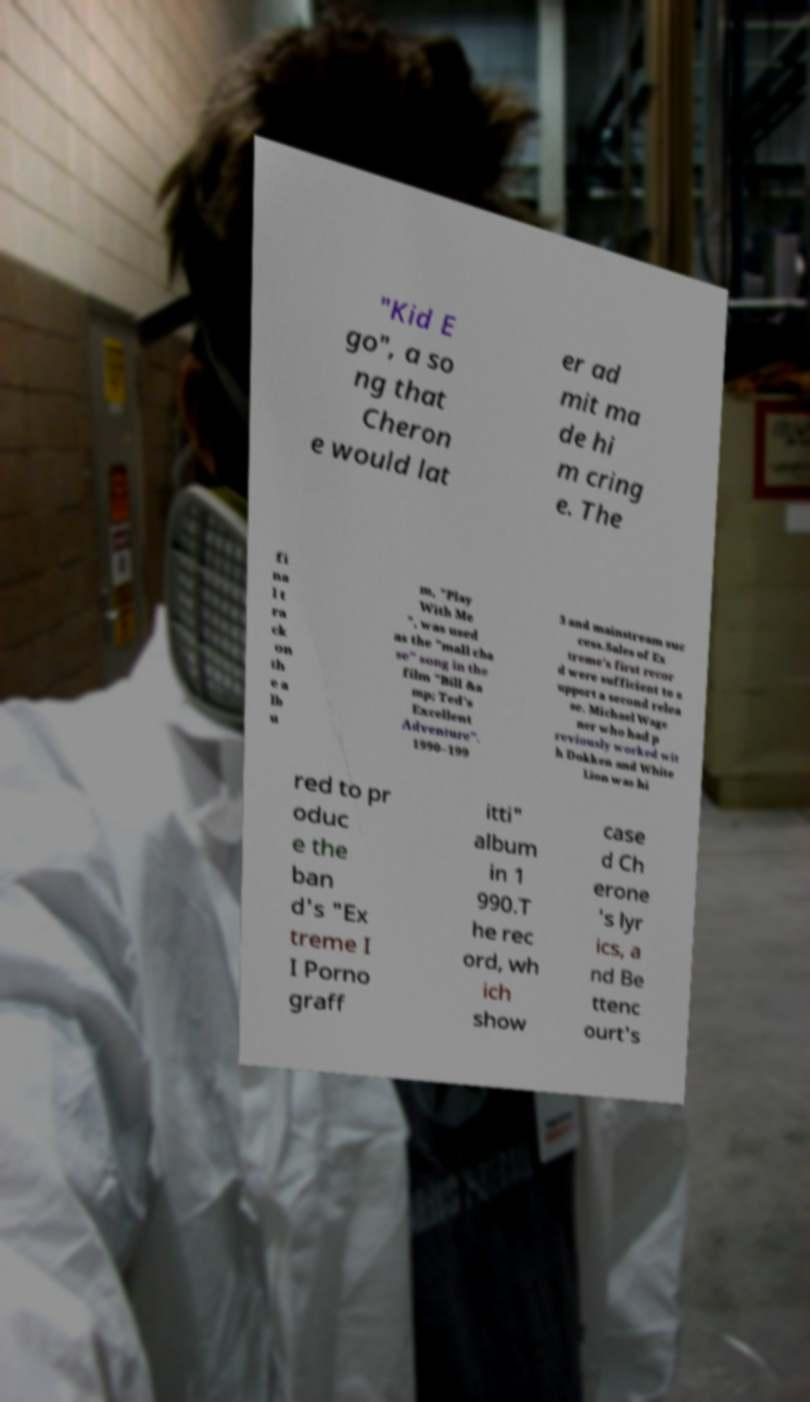Can you accurately transcribe the text from the provided image for me? "Kid E go", a so ng that Cheron e would lat er ad mit ma de hi m cring e. The fi na l t ra ck on th e a lb u m, "Play With Me ", was used as the "mall cha se" song in the film "Bill &a mp; Ted's Excellent Adventure". 1990–199 3 and mainstream suc cess.Sales of Ex treme's first recor d were sufficient to s upport a second relea se. Michael Wage ner who had p reviously worked wit h Dokken and White Lion was hi red to pr oduc e the ban d's "Ex treme I I Porno graff itti" album in 1 990.T he rec ord, wh ich show case d Ch erone 's lyr ics, a nd Be ttenc ourt's 